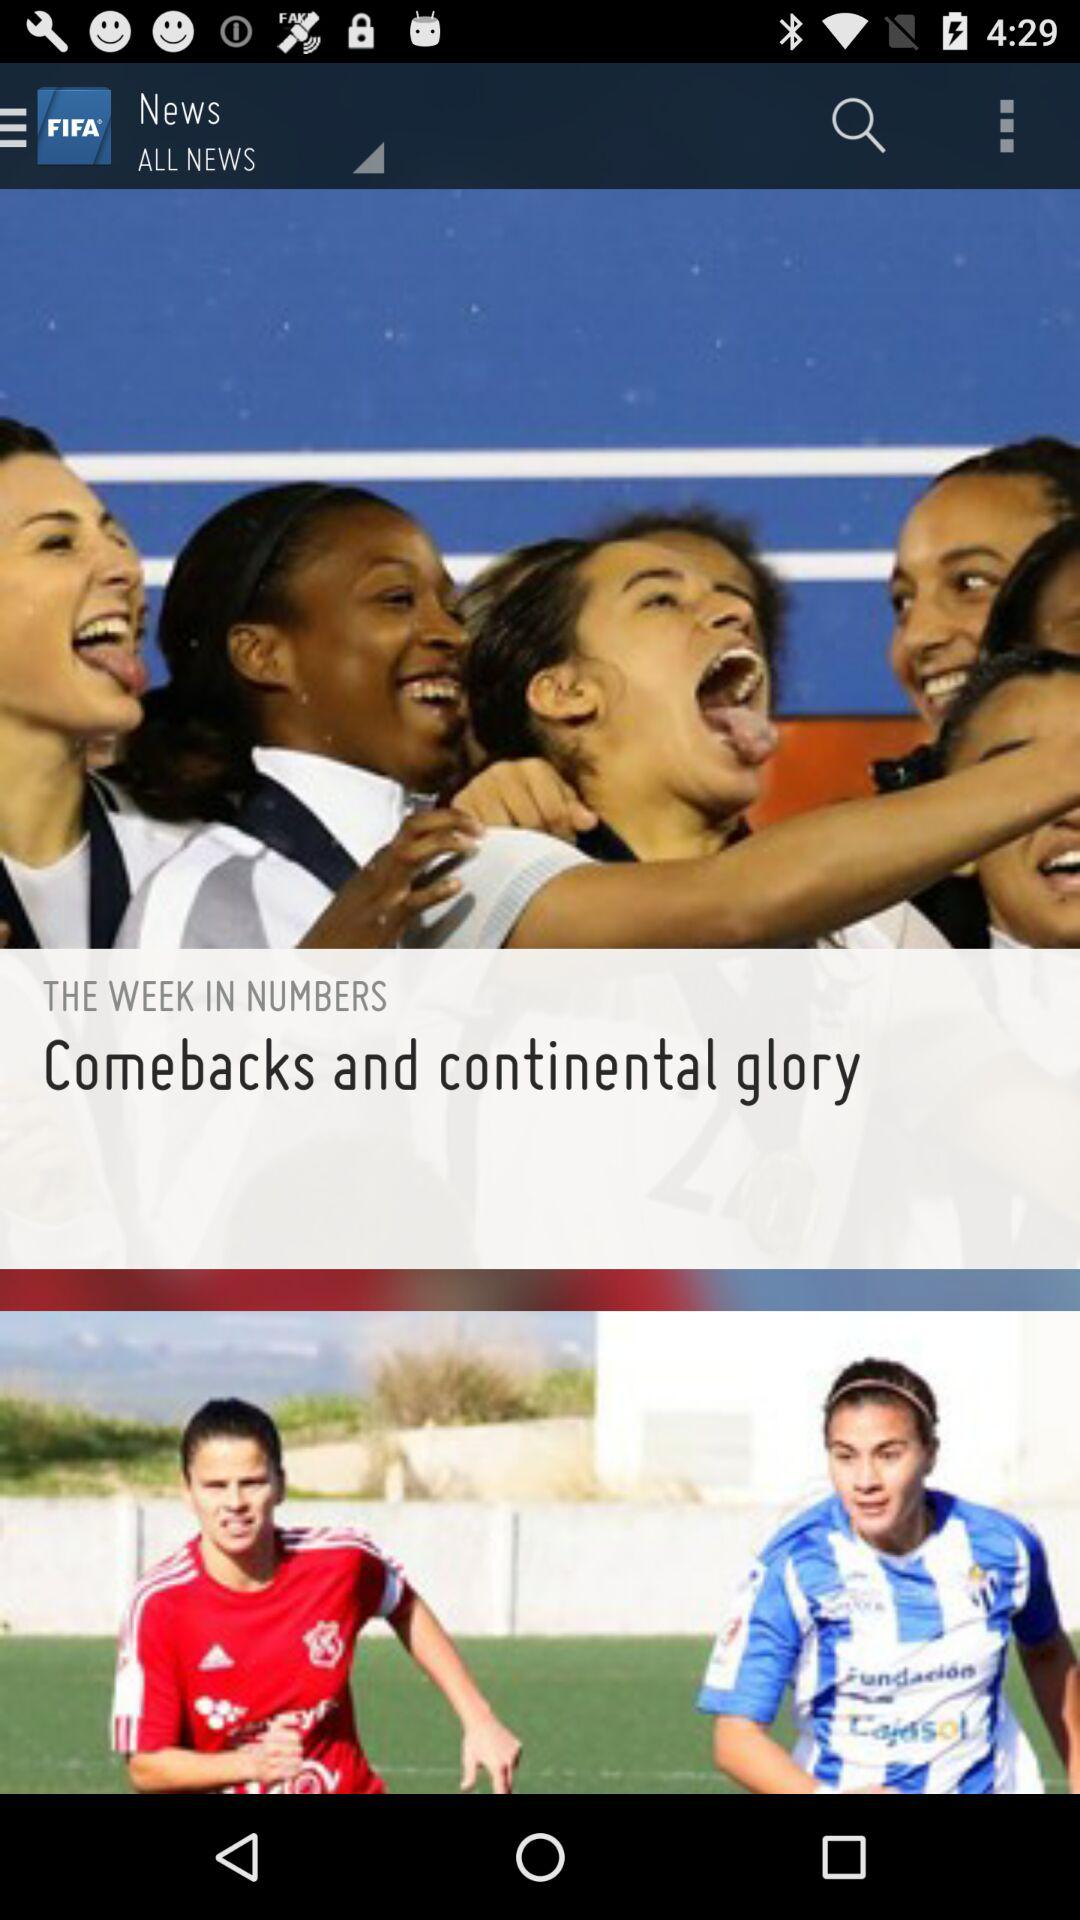What is the title of the news? The title of the news is "Comebacks and continental glory". 